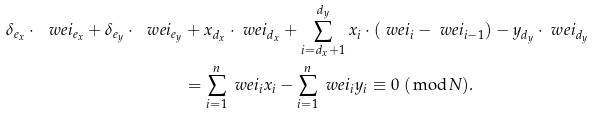Convert formula to latex. <formula><loc_0><loc_0><loc_500><loc_500>\delta _ { e _ { x } } \cdot \ w e i _ { e _ { x } } + \delta _ { e _ { y } } \cdot \ w e i _ { e _ { y } } & + x _ { d _ { x } } \cdot \ w e i _ { d _ { x } } + \sum _ { i = d _ { x } + 1 } ^ { d _ { y } } x _ { i } \cdot ( \ w e i _ { i } - \ w e i _ { i - 1 } ) - y _ { d _ { y } } \cdot \ w e i _ { d _ { y } } \\ & = \sum _ { i = 1 } ^ { n } \ w e i _ { i } x _ { i } - \sum _ { i = 1 } ^ { n } \ w e i _ { i } y _ { i } \equiv 0 \ ( \bmod N ) .</formula> 